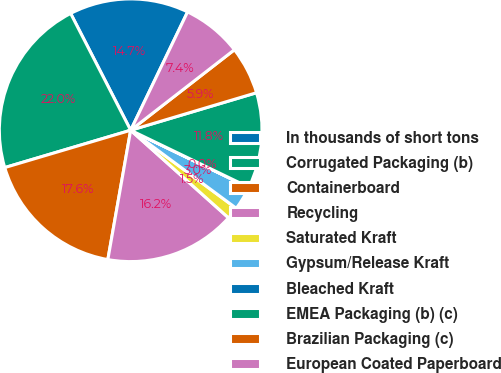Convert chart. <chart><loc_0><loc_0><loc_500><loc_500><pie_chart><fcel>In thousands of short tons<fcel>Corrugated Packaging (b)<fcel>Containerboard<fcel>Recycling<fcel>Saturated Kraft<fcel>Gypsum/Release Kraft<fcel>Bleached Kraft<fcel>EMEA Packaging (b) (c)<fcel>Brazilian Packaging (c)<fcel>European Coated Paperboard<nl><fcel>14.69%<fcel>22.03%<fcel>17.63%<fcel>16.16%<fcel>1.49%<fcel>2.96%<fcel>0.02%<fcel>11.76%<fcel>5.89%<fcel>7.36%<nl></chart> 